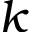<formula> <loc_0><loc_0><loc_500><loc_500>k</formula> 